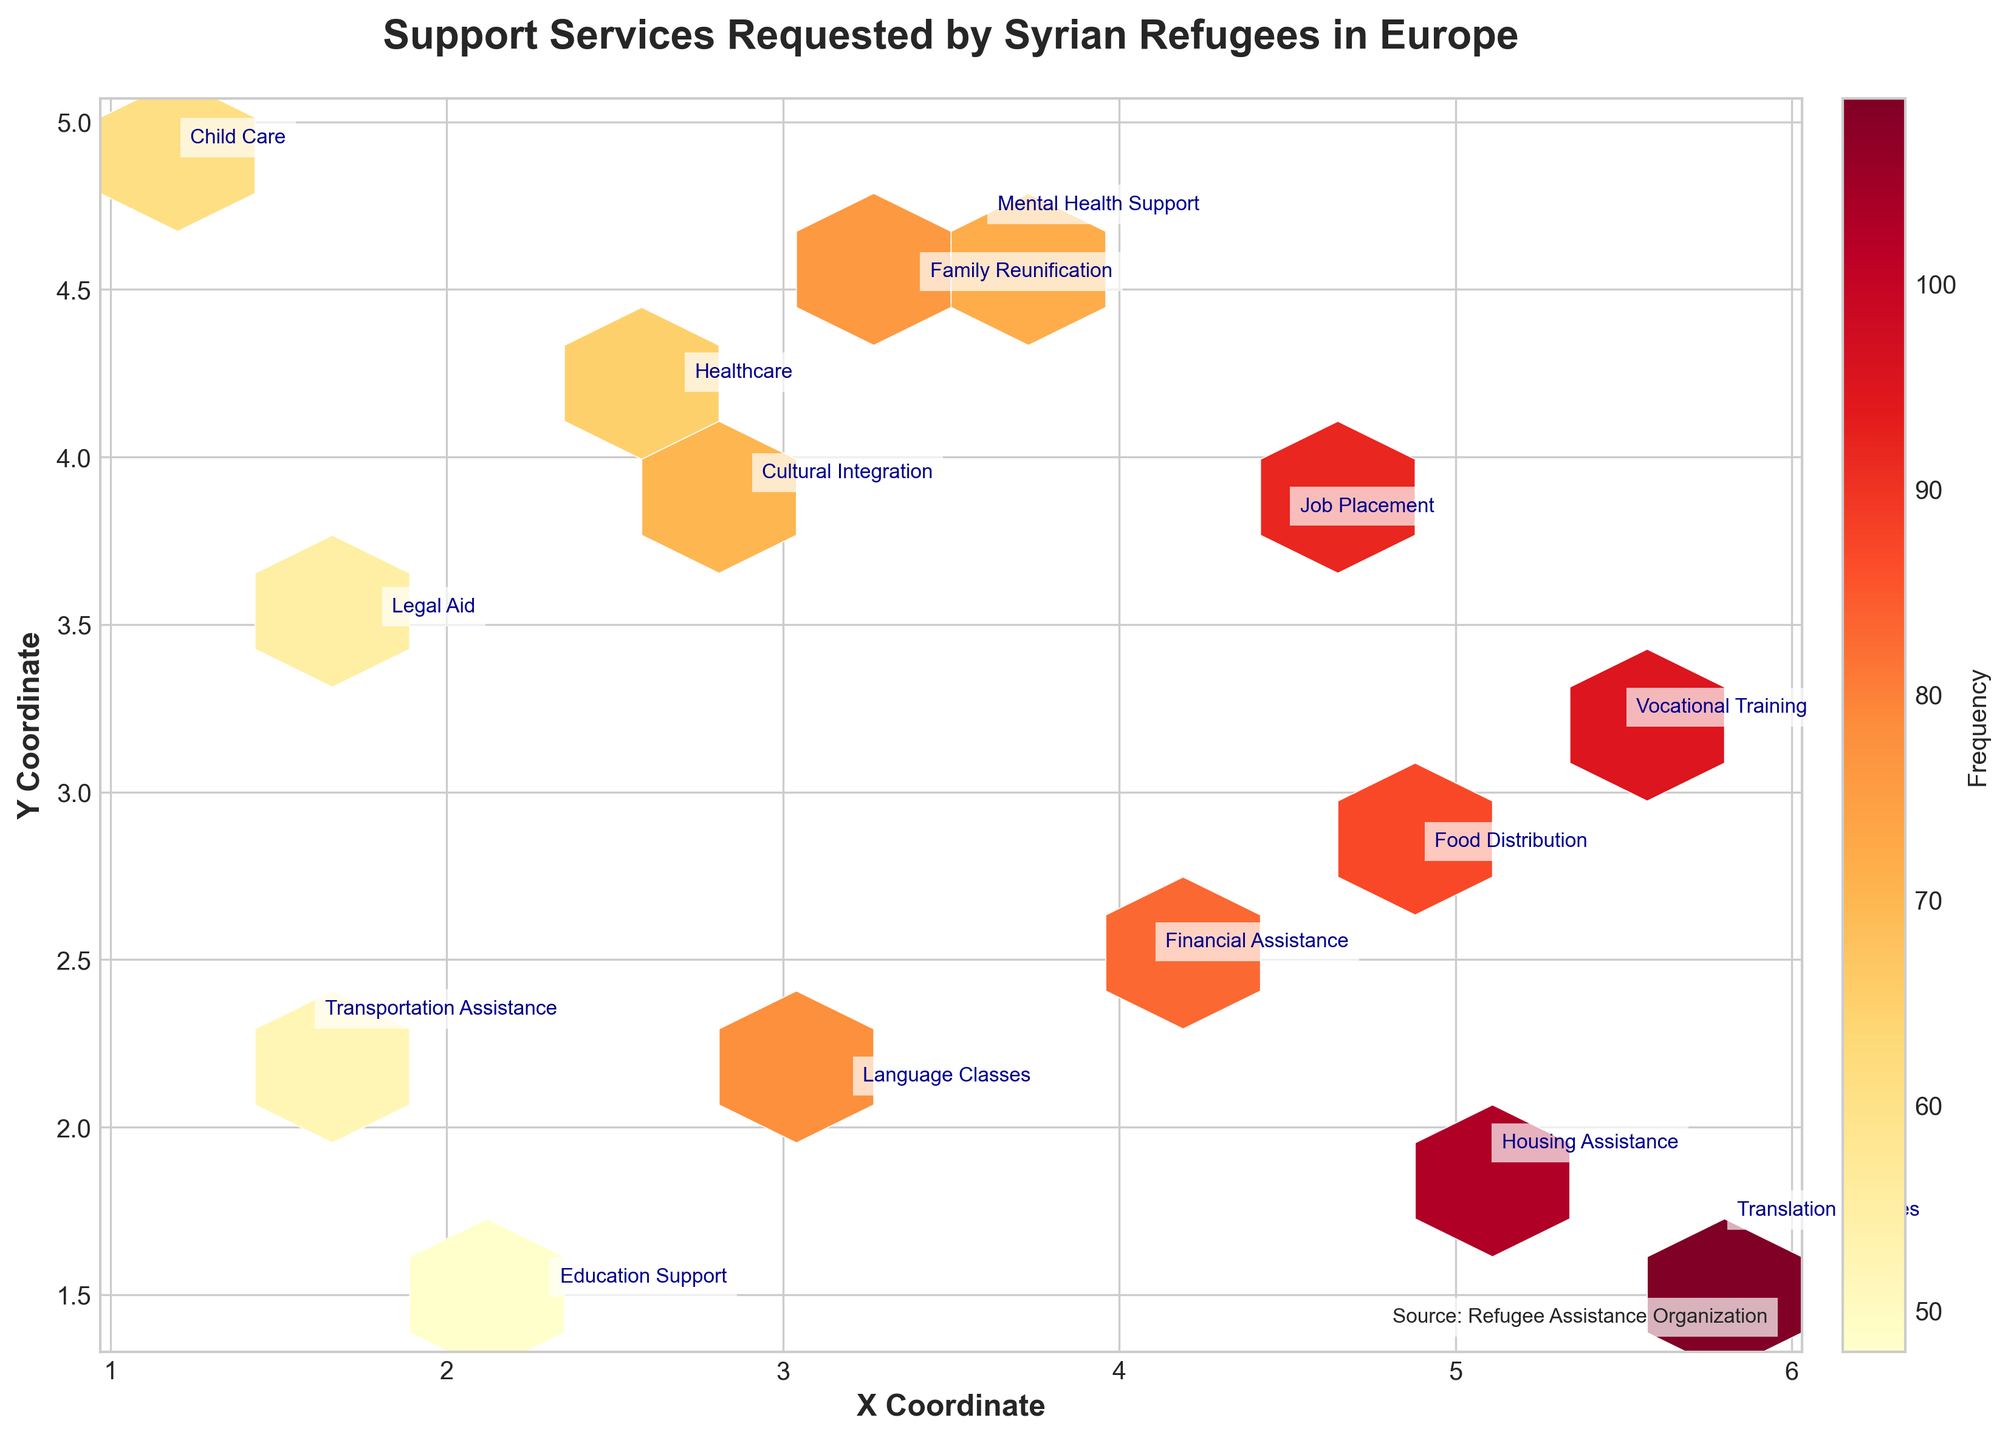What is the title of the plot? The title of the plot appears at the top and is clearly labeled in a larger, bold font. The title is "Support Services Requested by Syrian Refugees in Europe".
Answer: Support Services Requested by Syrian Refugees in Europe What does the color intensity represent in the hexbin plot? The color intensity in the hexbin plot represents the frequency of support service requests. Higher frequencies are denoted by darker shades, while lower frequencies are indicated by lighter shades.
Answer: Frequency Which region had the highest frequency of support services requested? By observing the color intensity in the hexbin plot, the darkest hexagon represents the highest frequency. The service with a frequency of 109 (Translation Services) is requested in the United Kingdom.
Answer: United Kingdom How many different types of support services are annotated on the plot? Each type of support service is annotated with labels on the plot. Counting these labels reveals that there are 15 different types of support services.
Answer: 15 In which region is "Housing Assistance" the most frequently requested service? By finding the label "Housing Assistance" on the plot and checking its coordinates and frequency, we see it is associated with the Netherlands.
Answer: Netherlands What is the average frequency of support services with coordinates (4.9, 2.8) and (1.8, 3.5)? First, identify the frequencies for the coordinates (4.9, 2.8) and (1.8, 3.5), which are 87 and 55, respectively. The average is calculated as (87 + 55) / 2.
Answer: 71 Which support service in France has a frequency of 65? By finding the label with a frequency of 65 and the corresponding coordinates and the service type, it's found that "Healthcare" is requested with this frequency in France.
Answer: Healthcare Compare the frequencies of "Job Placement" and "Housing Assistance". Which one is higher? By examining the hexagons and their frequencies for "Job Placement" and "Housing Assistance," the frequencies are 92 and 103, respectively. "Housing Assistance" has the higher frequency.
Answer: Housing Assistance What is the minimum frequency of support services requested among the given data points? By scanning the annotated frequencies on the plot, the minimum frequency observed is 48 for "Education Support" in Spain.
Answer: 48 